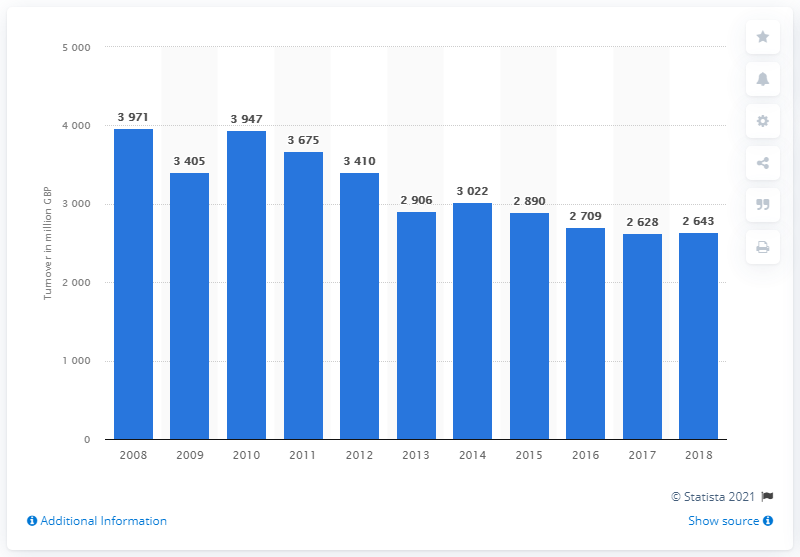Mention a couple of crucial points in this snapshot. In 2018, the turnover of newspapers and periodicals was 2709. 